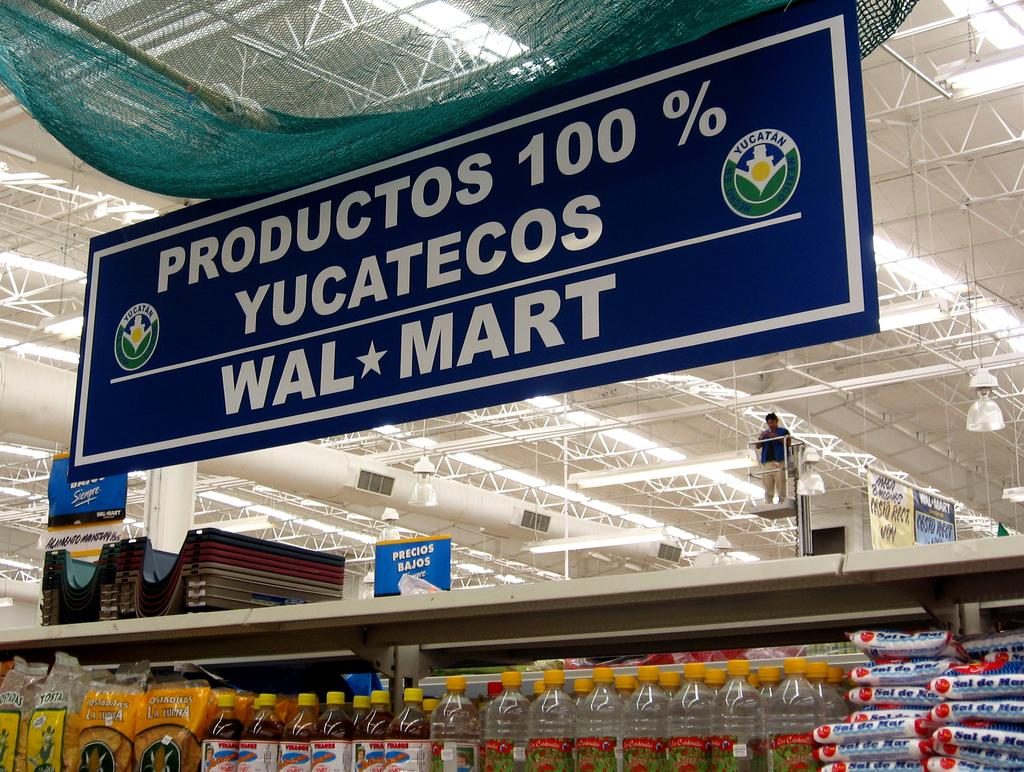<image>
Summarize the visual content of the image. A sign in a store that reads productos 100%, yucatecos, walmart. 